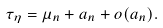<formula> <loc_0><loc_0><loc_500><loc_500>\tau _ { \eta } = \mu _ { n } + a _ { n } + o ( a _ { n } ) .</formula> 